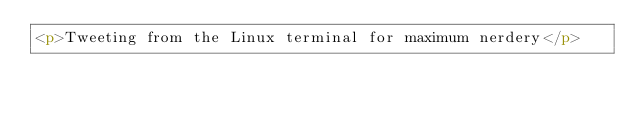Convert code to text. <code><loc_0><loc_0><loc_500><loc_500><_HTML_><p>Tweeting from the Linux terminal for maximum nerdery</p>
</code> 